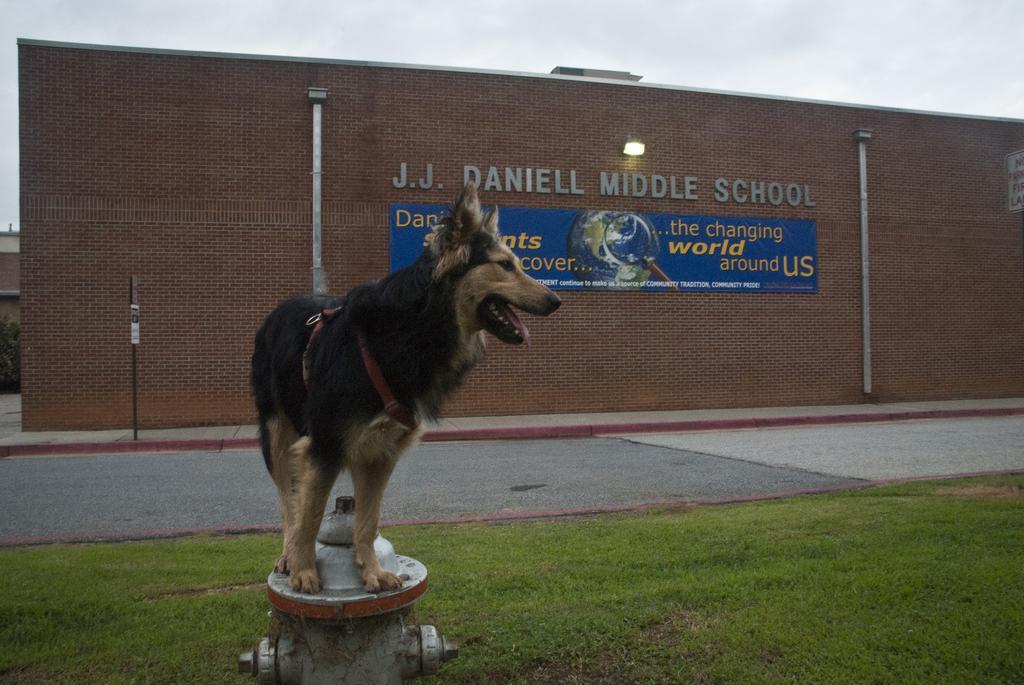Describe this image in one or two sentences. In the picture i can see a dog which is in brown and black color standing on fire hydrant, there is some grass and in the background i can see a wall to which a board is attached, there is light, some poles and top of the picture there is clear sky. 